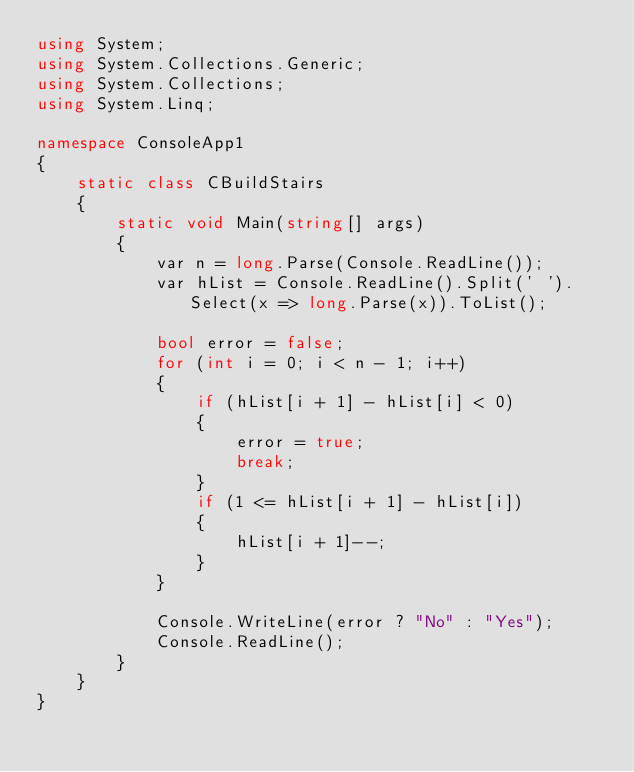<code> <loc_0><loc_0><loc_500><loc_500><_C#_>using System;
using System.Collections.Generic;
using System.Collections;
using System.Linq;

namespace ConsoleApp1
{
    static class CBuildStairs
    {
        static void Main(string[] args)
        {
            var n = long.Parse(Console.ReadLine());
            var hList = Console.ReadLine().Split(' ').Select(x => long.Parse(x)).ToList();

            bool error = false;
            for (int i = 0; i < n - 1; i++)
            {
                if (hList[i + 1] - hList[i] < 0)
                {
                    error = true;
                    break;
                }
                if (1 <= hList[i + 1] - hList[i])
                {
                    hList[i + 1]--;
                }
            }

            Console.WriteLine(error ? "No" : "Yes");
            Console.ReadLine();
        }
    }
}</code> 